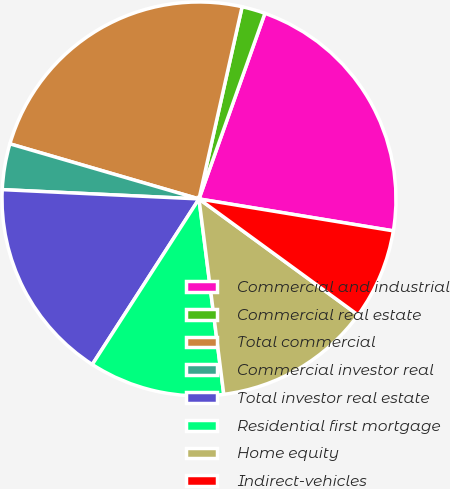Convert chart. <chart><loc_0><loc_0><loc_500><loc_500><pie_chart><fcel>Commercial and industrial<fcel>Commercial real estate<fcel>Total commercial<fcel>Commercial investor real<fcel>Total investor real estate<fcel>Residential first mortgage<fcel>Home equity<fcel>Indirect-vehicles<nl><fcel>22.16%<fcel>1.92%<fcel>24.0%<fcel>3.76%<fcel>16.64%<fcel>11.12%<fcel>12.96%<fcel>7.44%<nl></chart> 